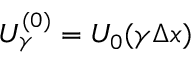<formula> <loc_0><loc_0><loc_500><loc_500>U _ { \gamma } ^ { ( 0 ) } = U _ { 0 } ( \gamma x )</formula> 